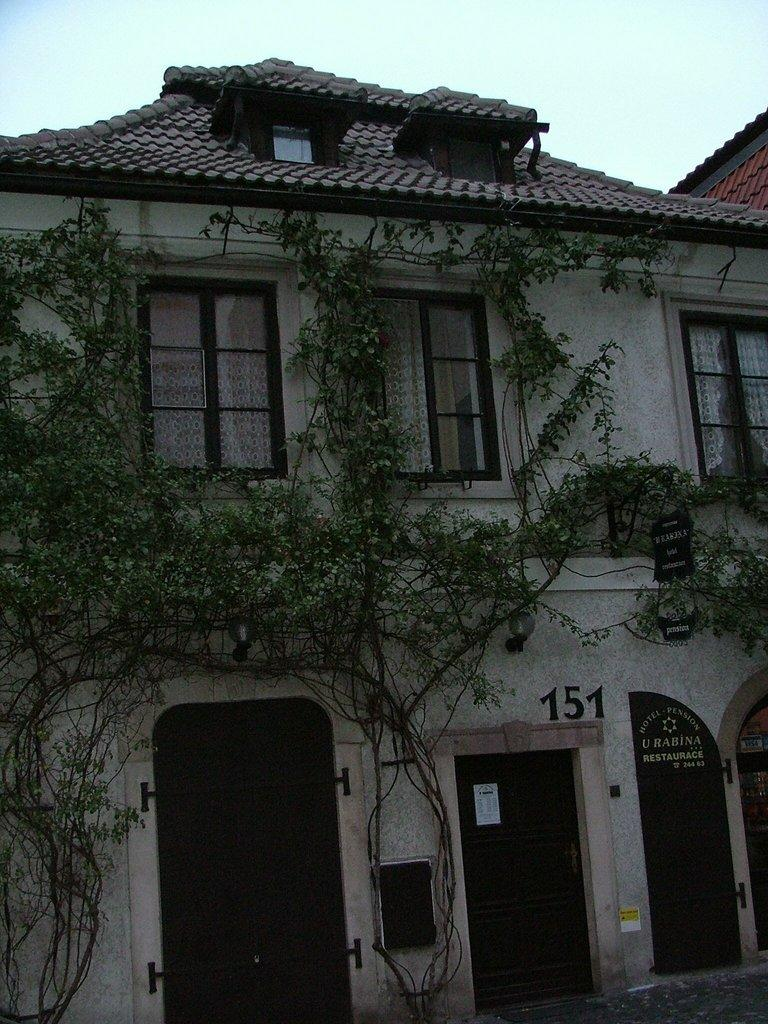What type of structures can be seen in the image? There are buildings in the image. What other elements are present in the image besides buildings? There are plants in the image. What is visible at the top of the image? The sky is visible at the top of the image. What type of fowl can be seen perched on the point of the building in the image? There is no fowl present in the image, and the buildings do not have any visible points. 